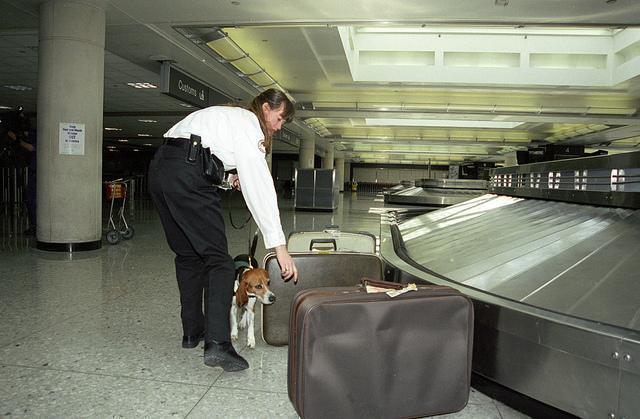How many suitcases are in the photo?
Give a very brief answer. 3. 